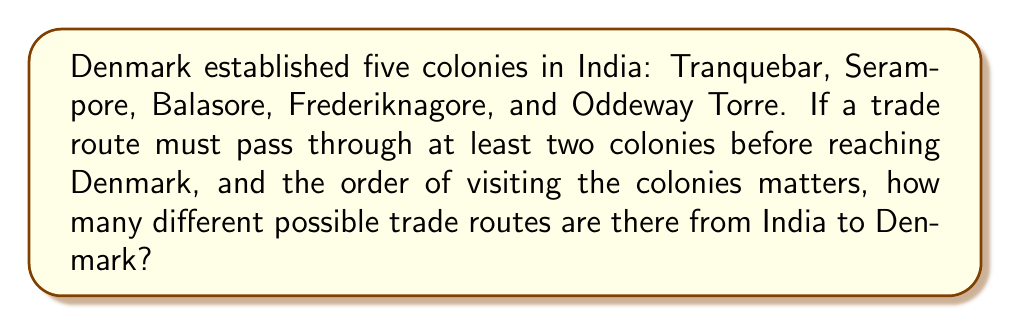Provide a solution to this math problem. Let's approach this step-by-step:

1) First, we need to understand that this is a permutation problem, as the order of visiting the colonies matters.

2) We need to consider routes that pass through 2, 3, 4, or all 5 colonies before reaching Denmark.

3) For routes passing through 2 colonies:
   - We choose 2 colonies out of 5: $\binom{5}{2}$
   - We arrange these 2 colonies: $2!$
   - Total: $\binom{5}{2} \cdot 2! = 10 \cdot 2 = 20$

4) For routes passing through 3 colonies:
   - We choose 3 colonies out of 5: $\binom{5}{3}$
   - We arrange these 3 colonies: $3!$
   - Total: $\binom{5}{3} \cdot 3! = 10 \cdot 6 = 60$

5) For routes passing through 4 colonies:
   - We choose 4 colonies out of 5: $\binom{5}{4}$
   - We arrange these 4 colonies: $4!$
   - Total: $\binom{5}{4} \cdot 4! = 5 \cdot 24 = 120$

6) For routes passing through all 5 colonies:
   - We arrange all 5 colonies: $5!$
   - Total: $5! = 120$

7) The total number of possible routes is the sum of all these possibilities:
   $20 + 60 + 120 + 120 = 320$

Therefore, there are 320 different possible trade routes from India to Denmark.
Answer: 320 